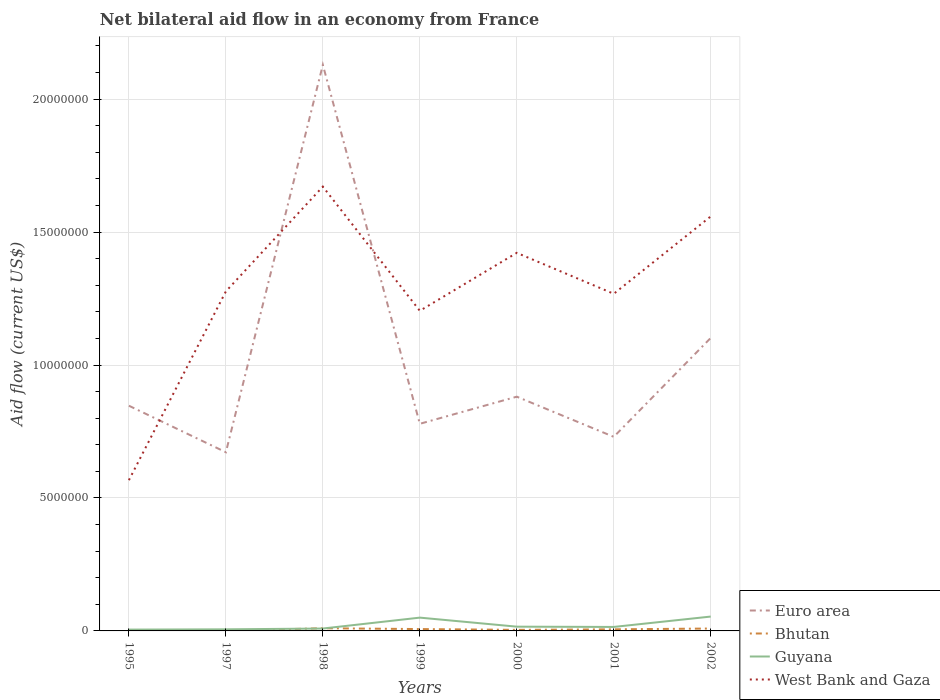How many different coloured lines are there?
Ensure brevity in your answer.  4. Does the line corresponding to Euro area intersect with the line corresponding to West Bank and Gaza?
Provide a succinct answer. Yes. Across all years, what is the maximum net bilateral aid flow in Euro area?
Ensure brevity in your answer.  6.72e+06. What is the total net bilateral aid flow in Euro area in the graph?
Offer a very short reply. -2.21e+06. What is the difference between the highest and the lowest net bilateral aid flow in West Bank and Gaza?
Your response must be concise. 3. Is the net bilateral aid flow in Euro area strictly greater than the net bilateral aid flow in West Bank and Gaza over the years?
Provide a short and direct response. No. How many years are there in the graph?
Your answer should be compact. 7. What is the difference between two consecutive major ticks on the Y-axis?
Give a very brief answer. 5.00e+06. Are the values on the major ticks of Y-axis written in scientific E-notation?
Ensure brevity in your answer.  No. Does the graph contain any zero values?
Keep it short and to the point. No. Does the graph contain grids?
Keep it short and to the point. Yes. How many legend labels are there?
Offer a very short reply. 4. How are the legend labels stacked?
Make the answer very short. Vertical. What is the title of the graph?
Keep it short and to the point. Net bilateral aid flow in an economy from France. Does "Armenia" appear as one of the legend labels in the graph?
Provide a succinct answer. No. What is the Aid flow (current US$) of Euro area in 1995?
Your answer should be compact. 8.47e+06. What is the Aid flow (current US$) of Bhutan in 1995?
Your response must be concise. 3.00e+04. What is the Aid flow (current US$) in West Bank and Gaza in 1995?
Offer a terse response. 5.67e+06. What is the Aid flow (current US$) of Euro area in 1997?
Ensure brevity in your answer.  6.72e+06. What is the Aid flow (current US$) in Bhutan in 1997?
Keep it short and to the point. 10000. What is the Aid flow (current US$) in Guyana in 1997?
Your response must be concise. 6.00e+04. What is the Aid flow (current US$) in West Bank and Gaza in 1997?
Make the answer very short. 1.28e+07. What is the Aid flow (current US$) of Euro area in 1998?
Offer a terse response. 2.13e+07. What is the Aid flow (current US$) in Guyana in 1998?
Your response must be concise. 9.00e+04. What is the Aid flow (current US$) in West Bank and Gaza in 1998?
Offer a very short reply. 1.67e+07. What is the Aid flow (current US$) in Euro area in 1999?
Provide a short and direct response. 7.79e+06. What is the Aid flow (current US$) of West Bank and Gaza in 1999?
Give a very brief answer. 1.20e+07. What is the Aid flow (current US$) of Euro area in 2000?
Offer a very short reply. 8.81e+06. What is the Aid flow (current US$) in Guyana in 2000?
Your answer should be compact. 1.60e+05. What is the Aid flow (current US$) in West Bank and Gaza in 2000?
Offer a very short reply. 1.42e+07. What is the Aid flow (current US$) of Euro area in 2001?
Your response must be concise. 7.30e+06. What is the Aid flow (current US$) in West Bank and Gaza in 2001?
Ensure brevity in your answer.  1.27e+07. What is the Aid flow (current US$) in Euro area in 2002?
Your answer should be compact. 1.10e+07. What is the Aid flow (current US$) of Bhutan in 2002?
Offer a very short reply. 9.00e+04. What is the Aid flow (current US$) of Guyana in 2002?
Provide a short and direct response. 5.40e+05. What is the Aid flow (current US$) in West Bank and Gaza in 2002?
Offer a terse response. 1.56e+07. Across all years, what is the maximum Aid flow (current US$) of Euro area?
Provide a short and direct response. 2.13e+07. Across all years, what is the maximum Aid flow (current US$) in Guyana?
Ensure brevity in your answer.  5.40e+05. Across all years, what is the maximum Aid flow (current US$) in West Bank and Gaza?
Your answer should be compact. 1.67e+07. Across all years, what is the minimum Aid flow (current US$) in Euro area?
Your response must be concise. 6.72e+06. Across all years, what is the minimum Aid flow (current US$) of Bhutan?
Provide a short and direct response. 10000. Across all years, what is the minimum Aid flow (current US$) in Guyana?
Provide a short and direct response. 5.00e+04. Across all years, what is the minimum Aid flow (current US$) in West Bank and Gaza?
Make the answer very short. 5.67e+06. What is the total Aid flow (current US$) of Euro area in the graph?
Provide a succinct answer. 7.14e+07. What is the total Aid flow (current US$) in Bhutan in the graph?
Your answer should be very brief. 4.00e+05. What is the total Aid flow (current US$) in Guyana in the graph?
Offer a terse response. 1.55e+06. What is the total Aid flow (current US$) of West Bank and Gaza in the graph?
Provide a succinct answer. 8.97e+07. What is the difference between the Aid flow (current US$) of Euro area in 1995 and that in 1997?
Your answer should be very brief. 1.75e+06. What is the difference between the Aid flow (current US$) of Bhutan in 1995 and that in 1997?
Provide a short and direct response. 2.00e+04. What is the difference between the Aid flow (current US$) of West Bank and Gaza in 1995 and that in 1997?
Give a very brief answer. -7.10e+06. What is the difference between the Aid flow (current US$) in Euro area in 1995 and that in 1998?
Keep it short and to the point. -1.28e+07. What is the difference between the Aid flow (current US$) of Bhutan in 1995 and that in 1998?
Give a very brief answer. -7.00e+04. What is the difference between the Aid flow (current US$) of Guyana in 1995 and that in 1998?
Make the answer very short. -4.00e+04. What is the difference between the Aid flow (current US$) of West Bank and Gaza in 1995 and that in 1998?
Provide a succinct answer. -1.10e+07. What is the difference between the Aid flow (current US$) in Euro area in 1995 and that in 1999?
Your response must be concise. 6.80e+05. What is the difference between the Aid flow (current US$) of Guyana in 1995 and that in 1999?
Ensure brevity in your answer.  -4.50e+05. What is the difference between the Aid flow (current US$) in West Bank and Gaza in 1995 and that in 1999?
Offer a terse response. -6.37e+06. What is the difference between the Aid flow (current US$) of Bhutan in 1995 and that in 2000?
Offer a very short reply. -10000. What is the difference between the Aid flow (current US$) in West Bank and Gaza in 1995 and that in 2000?
Keep it short and to the point. -8.55e+06. What is the difference between the Aid flow (current US$) of Euro area in 1995 and that in 2001?
Keep it short and to the point. 1.17e+06. What is the difference between the Aid flow (current US$) in Bhutan in 1995 and that in 2001?
Offer a very short reply. -3.00e+04. What is the difference between the Aid flow (current US$) of West Bank and Gaza in 1995 and that in 2001?
Ensure brevity in your answer.  -7.01e+06. What is the difference between the Aid flow (current US$) in Euro area in 1995 and that in 2002?
Your answer should be compact. -2.55e+06. What is the difference between the Aid flow (current US$) in Bhutan in 1995 and that in 2002?
Give a very brief answer. -6.00e+04. What is the difference between the Aid flow (current US$) in Guyana in 1995 and that in 2002?
Provide a short and direct response. -4.90e+05. What is the difference between the Aid flow (current US$) in West Bank and Gaza in 1995 and that in 2002?
Offer a terse response. -9.92e+06. What is the difference between the Aid flow (current US$) of Euro area in 1997 and that in 1998?
Make the answer very short. -1.46e+07. What is the difference between the Aid flow (current US$) in West Bank and Gaza in 1997 and that in 1998?
Provide a succinct answer. -3.94e+06. What is the difference between the Aid flow (current US$) of Euro area in 1997 and that in 1999?
Provide a short and direct response. -1.07e+06. What is the difference between the Aid flow (current US$) in Guyana in 1997 and that in 1999?
Provide a succinct answer. -4.40e+05. What is the difference between the Aid flow (current US$) in West Bank and Gaza in 1997 and that in 1999?
Ensure brevity in your answer.  7.30e+05. What is the difference between the Aid flow (current US$) in Euro area in 1997 and that in 2000?
Offer a very short reply. -2.09e+06. What is the difference between the Aid flow (current US$) in Bhutan in 1997 and that in 2000?
Your answer should be compact. -3.00e+04. What is the difference between the Aid flow (current US$) of Guyana in 1997 and that in 2000?
Offer a very short reply. -1.00e+05. What is the difference between the Aid flow (current US$) in West Bank and Gaza in 1997 and that in 2000?
Provide a succinct answer. -1.45e+06. What is the difference between the Aid flow (current US$) of Euro area in 1997 and that in 2001?
Give a very brief answer. -5.80e+05. What is the difference between the Aid flow (current US$) of Guyana in 1997 and that in 2001?
Make the answer very short. -9.00e+04. What is the difference between the Aid flow (current US$) in Euro area in 1997 and that in 2002?
Provide a short and direct response. -4.30e+06. What is the difference between the Aid flow (current US$) of Bhutan in 1997 and that in 2002?
Offer a very short reply. -8.00e+04. What is the difference between the Aid flow (current US$) in Guyana in 1997 and that in 2002?
Provide a short and direct response. -4.80e+05. What is the difference between the Aid flow (current US$) in West Bank and Gaza in 1997 and that in 2002?
Offer a very short reply. -2.82e+06. What is the difference between the Aid flow (current US$) of Euro area in 1998 and that in 1999?
Provide a succinct answer. 1.35e+07. What is the difference between the Aid flow (current US$) of Bhutan in 1998 and that in 1999?
Offer a very short reply. 3.00e+04. What is the difference between the Aid flow (current US$) in Guyana in 1998 and that in 1999?
Provide a succinct answer. -4.10e+05. What is the difference between the Aid flow (current US$) of West Bank and Gaza in 1998 and that in 1999?
Your answer should be very brief. 4.67e+06. What is the difference between the Aid flow (current US$) of Euro area in 1998 and that in 2000?
Make the answer very short. 1.25e+07. What is the difference between the Aid flow (current US$) in West Bank and Gaza in 1998 and that in 2000?
Ensure brevity in your answer.  2.49e+06. What is the difference between the Aid flow (current US$) in Euro area in 1998 and that in 2001?
Make the answer very short. 1.40e+07. What is the difference between the Aid flow (current US$) of Bhutan in 1998 and that in 2001?
Provide a succinct answer. 4.00e+04. What is the difference between the Aid flow (current US$) in West Bank and Gaza in 1998 and that in 2001?
Provide a succinct answer. 4.03e+06. What is the difference between the Aid flow (current US$) in Euro area in 1998 and that in 2002?
Your answer should be compact. 1.03e+07. What is the difference between the Aid flow (current US$) of Bhutan in 1998 and that in 2002?
Your response must be concise. 10000. What is the difference between the Aid flow (current US$) of Guyana in 1998 and that in 2002?
Your answer should be compact. -4.50e+05. What is the difference between the Aid flow (current US$) of West Bank and Gaza in 1998 and that in 2002?
Give a very brief answer. 1.12e+06. What is the difference between the Aid flow (current US$) in Euro area in 1999 and that in 2000?
Provide a succinct answer. -1.02e+06. What is the difference between the Aid flow (current US$) of West Bank and Gaza in 1999 and that in 2000?
Your answer should be compact. -2.18e+06. What is the difference between the Aid flow (current US$) in Euro area in 1999 and that in 2001?
Your answer should be very brief. 4.90e+05. What is the difference between the Aid flow (current US$) of Guyana in 1999 and that in 2001?
Your response must be concise. 3.50e+05. What is the difference between the Aid flow (current US$) of West Bank and Gaza in 1999 and that in 2001?
Offer a very short reply. -6.40e+05. What is the difference between the Aid flow (current US$) of Euro area in 1999 and that in 2002?
Make the answer very short. -3.23e+06. What is the difference between the Aid flow (current US$) of Bhutan in 1999 and that in 2002?
Provide a succinct answer. -2.00e+04. What is the difference between the Aid flow (current US$) of West Bank and Gaza in 1999 and that in 2002?
Provide a short and direct response. -3.55e+06. What is the difference between the Aid flow (current US$) of Euro area in 2000 and that in 2001?
Offer a terse response. 1.51e+06. What is the difference between the Aid flow (current US$) in Guyana in 2000 and that in 2001?
Your answer should be very brief. 10000. What is the difference between the Aid flow (current US$) of West Bank and Gaza in 2000 and that in 2001?
Ensure brevity in your answer.  1.54e+06. What is the difference between the Aid flow (current US$) of Euro area in 2000 and that in 2002?
Keep it short and to the point. -2.21e+06. What is the difference between the Aid flow (current US$) in Guyana in 2000 and that in 2002?
Keep it short and to the point. -3.80e+05. What is the difference between the Aid flow (current US$) in West Bank and Gaza in 2000 and that in 2002?
Keep it short and to the point. -1.37e+06. What is the difference between the Aid flow (current US$) in Euro area in 2001 and that in 2002?
Offer a very short reply. -3.72e+06. What is the difference between the Aid flow (current US$) of Bhutan in 2001 and that in 2002?
Offer a terse response. -3.00e+04. What is the difference between the Aid flow (current US$) of Guyana in 2001 and that in 2002?
Your response must be concise. -3.90e+05. What is the difference between the Aid flow (current US$) in West Bank and Gaza in 2001 and that in 2002?
Keep it short and to the point. -2.91e+06. What is the difference between the Aid flow (current US$) in Euro area in 1995 and the Aid flow (current US$) in Bhutan in 1997?
Ensure brevity in your answer.  8.46e+06. What is the difference between the Aid flow (current US$) in Euro area in 1995 and the Aid flow (current US$) in Guyana in 1997?
Keep it short and to the point. 8.41e+06. What is the difference between the Aid flow (current US$) of Euro area in 1995 and the Aid flow (current US$) of West Bank and Gaza in 1997?
Your answer should be compact. -4.30e+06. What is the difference between the Aid flow (current US$) in Bhutan in 1995 and the Aid flow (current US$) in West Bank and Gaza in 1997?
Make the answer very short. -1.27e+07. What is the difference between the Aid flow (current US$) in Guyana in 1995 and the Aid flow (current US$) in West Bank and Gaza in 1997?
Your answer should be very brief. -1.27e+07. What is the difference between the Aid flow (current US$) in Euro area in 1995 and the Aid flow (current US$) in Bhutan in 1998?
Your answer should be compact. 8.37e+06. What is the difference between the Aid flow (current US$) of Euro area in 1995 and the Aid flow (current US$) of Guyana in 1998?
Give a very brief answer. 8.38e+06. What is the difference between the Aid flow (current US$) in Euro area in 1995 and the Aid flow (current US$) in West Bank and Gaza in 1998?
Your answer should be compact. -8.24e+06. What is the difference between the Aid flow (current US$) of Bhutan in 1995 and the Aid flow (current US$) of West Bank and Gaza in 1998?
Ensure brevity in your answer.  -1.67e+07. What is the difference between the Aid flow (current US$) in Guyana in 1995 and the Aid flow (current US$) in West Bank and Gaza in 1998?
Give a very brief answer. -1.67e+07. What is the difference between the Aid flow (current US$) of Euro area in 1995 and the Aid flow (current US$) of Bhutan in 1999?
Your answer should be very brief. 8.40e+06. What is the difference between the Aid flow (current US$) in Euro area in 1995 and the Aid flow (current US$) in Guyana in 1999?
Provide a short and direct response. 7.97e+06. What is the difference between the Aid flow (current US$) of Euro area in 1995 and the Aid flow (current US$) of West Bank and Gaza in 1999?
Your answer should be very brief. -3.57e+06. What is the difference between the Aid flow (current US$) in Bhutan in 1995 and the Aid flow (current US$) in Guyana in 1999?
Offer a very short reply. -4.70e+05. What is the difference between the Aid flow (current US$) in Bhutan in 1995 and the Aid flow (current US$) in West Bank and Gaza in 1999?
Offer a very short reply. -1.20e+07. What is the difference between the Aid flow (current US$) of Guyana in 1995 and the Aid flow (current US$) of West Bank and Gaza in 1999?
Ensure brevity in your answer.  -1.20e+07. What is the difference between the Aid flow (current US$) in Euro area in 1995 and the Aid flow (current US$) in Bhutan in 2000?
Ensure brevity in your answer.  8.43e+06. What is the difference between the Aid flow (current US$) of Euro area in 1995 and the Aid flow (current US$) of Guyana in 2000?
Ensure brevity in your answer.  8.31e+06. What is the difference between the Aid flow (current US$) in Euro area in 1995 and the Aid flow (current US$) in West Bank and Gaza in 2000?
Offer a very short reply. -5.75e+06. What is the difference between the Aid flow (current US$) in Bhutan in 1995 and the Aid flow (current US$) in West Bank and Gaza in 2000?
Provide a succinct answer. -1.42e+07. What is the difference between the Aid flow (current US$) of Guyana in 1995 and the Aid flow (current US$) of West Bank and Gaza in 2000?
Your answer should be compact. -1.42e+07. What is the difference between the Aid flow (current US$) in Euro area in 1995 and the Aid flow (current US$) in Bhutan in 2001?
Make the answer very short. 8.41e+06. What is the difference between the Aid flow (current US$) in Euro area in 1995 and the Aid flow (current US$) in Guyana in 2001?
Provide a short and direct response. 8.32e+06. What is the difference between the Aid flow (current US$) in Euro area in 1995 and the Aid flow (current US$) in West Bank and Gaza in 2001?
Make the answer very short. -4.21e+06. What is the difference between the Aid flow (current US$) of Bhutan in 1995 and the Aid flow (current US$) of Guyana in 2001?
Offer a very short reply. -1.20e+05. What is the difference between the Aid flow (current US$) in Bhutan in 1995 and the Aid flow (current US$) in West Bank and Gaza in 2001?
Give a very brief answer. -1.26e+07. What is the difference between the Aid flow (current US$) in Guyana in 1995 and the Aid flow (current US$) in West Bank and Gaza in 2001?
Offer a very short reply. -1.26e+07. What is the difference between the Aid flow (current US$) of Euro area in 1995 and the Aid flow (current US$) of Bhutan in 2002?
Give a very brief answer. 8.38e+06. What is the difference between the Aid flow (current US$) of Euro area in 1995 and the Aid flow (current US$) of Guyana in 2002?
Provide a short and direct response. 7.93e+06. What is the difference between the Aid flow (current US$) of Euro area in 1995 and the Aid flow (current US$) of West Bank and Gaza in 2002?
Offer a very short reply. -7.12e+06. What is the difference between the Aid flow (current US$) in Bhutan in 1995 and the Aid flow (current US$) in Guyana in 2002?
Provide a succinct answer. -5.10e+05. What is the difference between the Aid flow (current US$) of Bhutan in 1995 and the Aid flow (current US$) of West Bank and Gaza in 2002?
Keep it short and to the point. -1.56e+07. What is the difference between the Aid flow (current US$) in Guyana in 1995 and the Aid flow (current US$) in West Bank and Gaza in 2002?
Make the answer very short. -1.55e+07. What is the difference between the Aid flow (current US$) of Euro area in 1997 and the Aid flow (current US$) of Bhutan in 1998?
Offer a terse response. 6.62e+06. What is the difference between the Aid flow (current US$) in Euro area in 1997 and the Aid flow (current US$) in Guyana in 1998?
Offer a very short reply. 6.63e+06. What is the difference between the Aid flow (current US$) in Euro area in 1997 and the Aid flow (current US$) in West Bank and Gaza in 1998?
Ensure brevity in your answer.  -9.99e+06. What is the difference between the Aid flow (current US$) in Bhutan in 1997 and the Aid flow (current US$) in Guyana in 1998?
Give a very brief answer. -8.00e+04. What is the difference between the Aid flow (current US$) of Bhutan in 1997 and the Aid flow (current US$) of West Bank and Gaza in 1998?
Your answer should be very brief. -1.67e+07. What is the difference between the Aid flow (current US$) in Guyana in 1997 and the Aid flow (current US$) in West Bank and Gaza in 1998?
Provide a short and direct response. -1.66e+07. What is the difference between the Aid flow (current US$) of Euro area in 1997 and the Aid flow (current US$) of Bhutan in 1999?
Your response must be concise. 6.65e+06. What is the difference between the Aid flow (current US$) of Euro area in 1997 and the Aid flow (current US$) of Guyana in 1999?
Make the answer very short. 6.22e+06. What is the difference between the Aid flow (current US$) of Euro area in 1997 and the Aid flow (current US$) of West Bank and Gaza in 1999?
Provide a succinct answer. -5.32e+06. What is the difference between the Aid flow (current US$) in Bhutan in 1997 and the Aid flow (current US$) in Guyana in 1999?
Ensure brevity in your answer.  -4.90e+05. What is the difference between the Aid flow (current US$) in Bhutan in 1997 and the Aid flow (current US$) in West Bank and Gaza in 1999?
Give a very brief answer. -1.20e+07. What is the difference between the Aid flow (current US$) of Guyana in 1997 and the Aid flow (current US$) of West Bank and Gaza in 1999?
Your answer should be compact. -1.20e+07. What is the difference between the Aid flow (current US$) in Euro area in 1997 and the Aid flow (current US$) in Bhutan in 2000?
Provide a succinct answer. 6.68e+06. What is the difference between the Aid flow (current US$) in Euro area in 1997 and the Aid flow (current US$) in Guyana in 2000?
Your answer should be very brief. 6.56e+06. What is the difference between the Aid flow (current US$) of Euro area in 1997 and the Aid flow (current US$) of West Bank and Gaza in 2000?
Keep it short and to the point. -7.50e+06. What is the difference between the Aid flow (current US$) in Bhutan in 1997 and the Aid flow (current US$) in West Bank and Gaza in 2000?
Give a very brief answer. -1.42e+07. What is the difference between the Aid flow (current US$) of Guyana in 1997 and the Aid flow (current US$) of West Bank and Gaza in 2000?
Provide a succinct answer. -1.42e+07. What is the difference between the Aid flow (current US$) in Euro area in 1997 and the Aid flow (current US$) in Bhutan in 2001?
Your answer should be very brief. 6.66e+06. What is the difference between the Aid flow (current US$) of Euro area in 1997 and the Aid flow (current US$) of Guyana in 2001?
Offer a terse response. 6.57e+06. What is the difference between the Aid flow (current US$) in Euro area in 1997 and the Aid flow (current US$) in West Bank and Gaza in 2001?
Ensure brevity in your answer.  -5.96e+06. What is the difference between the Aid flow (current US$) in Bhutan in 1997 and the Aid flow (current US$) in West Bank and Gaza in 2001?
Your response must be concise. -1.27e+07. What is the difference between the Aid flow (current US$) in Guyana in 1997 and the Aid flow (current US$) in West Bank and Gaza in 2001?
Your answer should be very brief. -1.26e+07. What is the difference between the Aid flow (current US$) in Euro area in 1997 and the Aid flow (current US$) in Bhutan in 2002?
Your response must be concise. 6.63e+06. What is the difference between the Aid flow (current US$) in Euro area in 1997 and the Aid flow (current US$) in Guyana in 2002?
Give a very brief answer. 6.18e+06. What is the difference between the Aid flow (current US$) of Euro area in 1997 and the Aid flow (current US$) of West Bank and Gaza in 2002?
Your answer should be very brief. -8.87e+06. What is the difference between the Aid flow (current US$) in Bhutan in 1997 and the Aid flow (current US$) in Guyana in 2002?
Your answer should be very brief. -5.30e+05. What is the difference between the Aid flow (current US$) of Bhutan in 1997 and the Aid flow (current US$) of West Bank and Gaza in 2002?
Your response must be concise. -1.56e+07. What is the difference between the Aid flow (current US$) of Guyana in 1997 and the Aid flow (current US$) of West Bank and Gaza in 2002?
Your response must be concise. -1.55e+07. What is the difference between the Aid flow (current US$) in Euro area in 1998 and the Aid flow (current US$) in Bhutan in 1999?
Give a very brief answer. 2.12e+07. What is the difference between the Aid flow (current US$) of Euro area in 1998 and the Aid flow (current US$) of Guyana in 1999?
Offer a terse response. 2.08e+07. What is the difference between the Aid flow (current US$) in Euro area in 1998 and the Aid flow (current US$) in West Bank and Gaza in 1999?
Offer a terse response. 9.25e+06. What is the difference between the Aid flow (current US$) of Bhutan in 1998 and the Aid flow (current US$) of Guyana in 1999?
Your response must be concise. -4.00e+05. What is the difference between the Aid flow (current US$) in Bhutan in 1998 and the Aid flow (current US$) in West Bank and Gaza in 1999?
Give a very brief answer. -1.19e+07. What is the difference between the Aid flow (current US$) in Guyana in 1998 and the Aid flow (current US$) in West Bank and Gaza in 1999?
Provide a succinct answer. -1.20e+07. What is the difference between the Aid flow (current US$) of Euro area in 1998 and the Aid flow (current US$) of Bhutan in 2000?
Provide a succinct answer. 2.12e+07. What is the difference between the Aid flow (current US$) in Euro area in 1998 and the Aid flow (current US$) in Guyana in 2000?
Keep it short and to the point. 2.11e+07. What is the difference between the Aid flow (current US$) in Euro area in 1998 and the Aid flow (current US$) in West Bank and Gaza in 2000?
Make the answer very short. 7.07e+06. What is the difference between the Aid flow (current US$) in Bhutan in 1998 and the Aid flow (current US$) in Guyana in 2000?
Your answer should be compact. -6.00e+04. What is the difference between the Aid flow (current US$) of Bhutan in 1998 and the Aid flow (current US$) of West Bank and Gaza in 2000?
Provide a short and direct response. -1.41e+07. What is the difference between the Aid flow (current US$) in Guyana in 1998 and the Aid flow (current US$) in West Bank and Gaza in 2000?
Provide a short and direct response. -1.41e+07. What is the difference between the Aid flow (current US$) in Euro area in 1998 and the Aid flow (current US$) in Bhutan in 2001?
Offer a very short reply. 2.12e+07. What is the difference between the Aid flow (current US$) of Euro area in 1998 and the Aid flow (current US$) of Guyana in 2001?
Offer a terse response. 2.11e+07. What is the difference between the Aid flow (current US$) in Euro area in 1998 and the Aid flow (current US$) in West Bank and Gaza in 2001?
Offer a terse response. 8.61e+06. What is the difference between the Aid flow (current US$) in Bhutan in 1998 and the Aid flow (current US$) in Guyana in 2001?
Provide a short and direct response. -5.00e+04. What is the difference between the Aid flow (current US$) in Bhutan in 1998 and the Aid flow (current US$) in West Bank and Gaza in 2001?
Offer a very short reply. -1.26e+07. What is the difference between the Aid flow (current US$) in Guyana in 1998 and the Aid flow (current US$) in West Bank and Gaza in 2001?
Provide a short and direct response. -1.26e+07. What is the difference between the Aid flow (current US$) of Euro area in 1998 and the Aid flow (current US$) of Bhutan in 2002?
Make the answer very short. 2.12e+07. What is the difference between the Aid flow (current US$) of Euro area in 1998 and the Aid flow (current US$) of Guyana in 2002?
Your response must be concise. 2.08e+07. What is the difference between the Aid flow (current US$) of Euro area in 1998 and the Aid flow (current US$) of West Bank and Gaza in 2002?
Make the answer very short. 5.70e+06. What is the difference between the Aid flow (current US$) of Bhutan in 1998 and the Aid flow (current US$) of Guyana in 2002?
Your answer should be very brief. -4.40e+05. What is the difference between the Aid flow (current US$) of Bhutan in 1998 and the Aid flow (current US$) of West Bank and Gaza in 2002?
Offer a very short reply. -1.55e+07. What is the difference between the Aid flow (current US$) of Guyana in 1998 and the Aid flow (current US$) of West Bank and Gaza in 2002?
Offer a very short reply. -1.55e+07. What is the difference between the Aid flow (current US$) in Euro area in 1999 and the Aid flow (current US$) in Bhutan in 2000?
Make the answer very short. 7.75e+06. What is the difference between the Aid flow (current US$) in Euro area in 1999 and the Aid flow (current US$) in Guyana in 2000?
Your response must be concise. 7.63e+06. What is the difference between the Aid flow (current US$) of Euro area in 1999 and the Aid flow (current US$) of West Bank and Gaza in 2000?
Provide a short and direct response. -6.43e+06. What is the difference between the Aid flow (current US$) in Bhutan in 1999 and the Aid flow (current US$) in Guyana in 2000?
Give a very brief answer. -9.00e+04. What is the difference between the Aid flow (current US$) in Bhutan in 1999 and the Aid flow (current US$) in West Bank and Gaza in 2000?
Offer a very short reply. -1.42e+07. What is the difference between the Aid flow (current US$) of Guyana in 1999 and the Aid flow (current US$) of West Bank and Gaza in 2000?
Provide a succinct answer. -1.37e+07. What is the difference between the Aid flow (current US$) in Euro area in 1999 and the Aid flow (current US$) in Bhutan in 2001?
Offer a very short reply. 7.73e+06. What is the difference between the Aid flow (current US$) in Euro area in 1999 and the Aid flow (current US$) in Guyana in 2001?
Offer a very short reply. 7.64e+06. What is the difference between the Aid flow (current US$) in Euro area in 1999 and the Aid flow (current US$) in West Bank and Gaza in 2001?
Make the answer very short. -4.89e+06. What is the difference between the Aid flow (current US$) in Bhutan in 1999 and the Aid flow (current US$) in West Bank and Gaza in 2001?
Ensure brevity in your answer.  -1.26e+07. What is the difference between the Aid flow (current US$) in Guyana in 1999 and the Aid flow (current US$) in West Bank and Gaza in 2001?
Your answer should be very brief. -1.22e+07. What is the difference between the Aid flow (current US$) in Euro area in 1999 and the Aid flow (current US$) in Bhutan in 2002?
Make the answer very short. 7.70e+06. What is the difference between the Aid flow (current US$) in Euro area in 1999 and the Aid flow (current US$) in Guyana in 2002?
Provide a succinct answer. 7.25e+06. What is the difference between the Aid flow (current US$) in Euro area in 1999 and the Aid flow (current US$) in West Bank and Gaza in 2002?
Give a very brief answer. -7.80e+06. What is the difference between the Aid flow (current US$) in Bhutan in 1999 and the Aid flow (current US$) in Guyana in 2002?
Your answer should be very brief. -4.70e+05. What is the difference between the Aid flow (current US$) in Bhutan in 1999 and the Aid flow (current US$) in West Bank and Gaza in 2002?
Give a very brief answer. -1.55e+07. What is the difference between the Aid flow (current US$) in Guyana in 1999 and the Aid flow (current US$) in West Bank and Gaza in 2002?
Ensure brevity in your answer.  -1.51e+07. What is the difference between the Aid flow (current US$) in Euro area in 2000 and the Aid flow (current US$) in Bhutan in 2001?
Your response must be concise. 8.75e+06. What is the difference between the Aid flow (current US$) of Euro area in 2000 and the Aid flow (current US$) of Guyana in 2001?
Offer a terse response. 8.66e+06. What is the difference between the Aid flow (current US$) in Euro area in 2000 and the Aid flow (current US$) in West Bank and Gaza in 2001?
Make the answer very short. -3.87e+06. What is the difference between the Aid flow (current US$) of Bhutan in 2000 and the Aid flow (current US$) of Guyana in 2001?
Provide a succinct answer. -1.10e+05. What is the difference between the Aid flow (current US$) in Bhutan in 2000 and the Aid flow (current US$) in West Bank and Gaza in 2001?
Your response must be concise. -1.26e+07. What is the difference between the Aid flow (current US$) in Guyana in 2000 and the Aid flow (current US$) in West Bank and Gaza in 2001?
Your answer should be compact. -1.25e+07. What is the difference between the Aid flow (current US$) of Euro area in 2000 and the Aid flow (current US$) of Bhutan in 2002?
Keep it short and to the point. 8.72e+06. What is the difference between the Aid flow (current US$) of Euro area in 2000 and the Aid flow (current US$) of Guyana in 2002?
Offer a terse response. 8.27e+06. What is the difference between the Aid flow (current US$) in Euro area in 2000 and the Aid flow (current US$) in West Bank and Gaza in 2002?
Your response must be concise. -6.78e+06. What is the difference between the Aid flow (current US$) in Bhutan in 2000 and the Aid flow (current US$) in Guyana in 2002?
Your answer should be very brief. -5.00e+05. What is the difference between the Aid flow (current US$) of Bhutan in 2000 and the Aid flow (current US$) of West Bank and Gaza in 2002?
Offer a terse response. -1.56e+07. What is the difference between the Aid flow (current US$) in Guyana in 2000 and the Aid flow (current US$) in West Bank and Gaza in 2002?
Provide a succinct answer. -1.54e+07. What is the difference between the Aid flow (current US$) of Euro area in 2001 and the Aid flow (current US$) of Bhutan in 2002?
Make the answer very short. 7.21e+06. What is the difference between the Aid flow (current US$) in Euro area in 2001 and the Aid flow (current US$) in Guyana in 2002?
Give a very brief answer. 6.76e+06. What is the difference between the Aid flow (current US$) in Euro area in 2001 and the Aid flow (current US$) in West Bank and Gaza in 2002?
Offer a terse response. -8.29e+06. What is the difference between the Aid flow (current US$) of Bhutan in 2001 and the Aid flow (current US$) of Guyana in 2002?
Your answer should be very brief. -4.80e+05. What is the difference between the Aid flow (current US$) of Bhutan in 2001 and the Aid flow (current US$) of West Bank and Gaza in 2002?
Offer a very short reply. -1.55e+07. What is the difference between the Aid flow (current US$) in Guyana in 2001 and the Aid flow (current US$) in West Bank and Gaza in 2002?
Offer a terse response. -1.54e+07. What is the average Aid flow (current US$) of Euro area per year?
Keep it short and to the point. 1.02e+07. What is the average Aid flow (current US$) in Bhutan per year?
Offer a terse response. 5.71e+04. What is the average Aid flow (current US$) of Guyana per year?
Offer a very short reply. 2.21e+05. What is the average Aid flow (current US$) of West Bank and Gaza per year?
Offer a terse response. 1.28e+07. In the year 1995, what is the difference between the Aid flow (current US$) in Euro area and Aid flow (current US$) in Bhutan?
Keep it short and to the point. 8.44e+06. In the year 1995, what is the difference between the Aid flow (current US$) in Euro area and Aid flow (current US$) in Guyana?
Keep it short and to the point. 8.42e+06. In the year 1995, what is the difference between the Aid flow (current US$) in Euro area and Aid flow (current US$) in West Bank and Gaza?
Your answer should be compact. 2.80e+06. In the year 1995, what is the difference between the Aid flow (current US$) of Bhutan and Aid flow (current US$) of West Bank and Gaza?
Offer a very short reply. -5.64e+06. In the year 1995, what is the difference between the Aid flow (current US$) in Guyana and Aid flow (current US$) in West Bank and Gaza?
Give a very brief answer. -5.62e+06. In the year 1997, what is the difference between the Aid flow (current US$) in Euro area and Aid flow (current US$) in Bhutan?
Offer a very short reply. 6.71e+06. In the year 1997, what is the difference between the Aid flow (current US$) of Euro area and Aid flow (current US$) of Guyana?
Provide a succinct answer. 6.66e+06. In the year 1997, what is the difference between the Aid flow (current US$) in Euro area and Aid flow (current US$) in West Bank and Gaza?
Ensure brevity in your answer.  -6.05e+06. In the year 1997, what is the difference between the Aid flow (current US$) in Bhutan and Aid flow (current US$) in West Bank and Gaza?
Offer a very short reply. -1.28e+07. In the year 1997, what is the difference between the Aid flow (current US$) in Guyana and Aid flow (current US$) in West Bank and Gaza?
Make the answer very short. -1.27e+07. In the year 1998, what is the difference between the Aid flow (current US$) in Euro area and Aid flow (current US$) in Bhutan?
Offer a very short reply. 2.12e+07. In the year 1998, what is the difference between the Aid flow (current US$) in Euro area and Aid flow (current US$) in Guyana?
Offer a terse response. 2.12e+07. In the year 1998, what is the difference between the Aid flow (current US$) of Euro area and Aid flow (current US$) of West Bank and Gaza?
Provide a short and direct response. 4.58e+06. In the year 1998, what is the difference between the Aid flow (current US$) in Bhutan and Aid flow (current US$) in West Bank and Gaza?
Your answer should be very brief. -1.66e+07. In the year 1998, what is the difference between the Aid flow (current US$) in Guyana and Aid flow (current US$) in West Bank and Gaza?
Your answer should be very brief. -1.66e+07. In the year 1999, what is the difference between the Aid flow (current US$) of Euro area and Aid flow (current US$) of Bhutan?
Provide a short and direct response. 7.72e+06. In the year 1999, what is the difference between the Aid flow (current US$) in Euro area and Aid flow (current US$) in Guyana?
Make the answer very short. 7.29e+06. In the year 1999, what is the difference between the Aid flow (current US$) of Euro area and Aid flow (current US$) of West Bank and Gaza?
Offer a very short reply. -4.25e+06. In the year 1999, what is the difference between the Aid flow (current US$) of Bhutan and Aid flow (current US$) of Guyana?
Your answer should be compact. -4.30e+05. In the year 1999, what is the difference between the Aid flow (current US$) of Bhutan and Aid flow (current US$) of West Bank and Gaza?
Keep it short and to the point. -1.20e+07. In the year 1999, what is the difference between the Aid flow (current US$) in Guyana and Aid flow (current US$) in West Bank and Gaza?
Your response must be concise. -1.15e+07. In the year 2000, what is the difference between the Aid flow (current US$) in Euro area and Aid flow (current US$) in Bhutan?
Offer a very short reply. 8.77e+06. In the year 2000, what is the difference between the Aid flow (current US$) of Euro area and Aid flow (current US$) of Guyana?
Your response must be concise. 8.65e+06. In the year 2000, what is the difference between the Aid flow (current US$) in Euro area and Aid flow (current US$) in West Bank and Gaza?
Keep it short and to the point. -5.41e+06. In the year 2000, what is the difference between the Aid flow (current US$) in Bhutan and Aid flow (current US$) in West Bank and Gaza?
Offer a very short reply. -1.42e+07. In the year 2000, what is the difference between the Aid flow (current US$) in Guyana and Aid flow (current US$) in West Bank and Gaza?
Provide a short and direct response. -1.41e+07. In the year 2001, what is the difference between the Aid flow (current US$) of Euro area and Aid flow (current US$) of Bhutan?
Offer a very short reply. 7.24e+06. In the year 2001, what is the difference between the Aid flow (current US$) in Euro area and Aid flow (current US$) in Guyana?
Your answer should be very brief. 7.15e+06. In the year 2001, what is the difference between the Aid flow (current US$) of Euro area and Aid flow (current US$) of West Bank and Gaza?
Your response must be concise. -5.38e+06. In the year 2001, what is the difference between the Aid flow (current US$) in Bhutan and Aid flow (current US$) in Guyana?
Offer a terse response. -9.00e+04. In the year 2001, what is the difference between the Aid flow (current US$) of Bhutan and Aid flow (current US$) of West Bank and Gaza?
Make the answer very short. -1.26e+07. In the year 2001, what is the difference between the Aid flow (current US$) of Guyana and Aid flow (current US$) of West Bank and Gaza?
Your answer should be compact. -1.25e+07. In the year 2002, what is the difference between the Aid flow (current US$) in Euro area and Aid flow (current US$) in Bhutan?
Provide a succinct answer. 1.09e+07. In the year 2002, what is the difference between the Aid flow (current US$) of Euro area and Aid flow (current US$) of Guyana?
Give a very brief answer. 1.05e+07. In the year 2002, what is the difference between the Aid flow (current US$) of Euro area and Aid flow (current US$) of West Bank and Gaza?
Ensure brevity in your answer.  -4.57e+06. In the year 2002, what is the difference between the Aid flow (current US$) of Bhutan and Aid flow (current US$) of Guyana?
Give a very brief answer. -4.50e+05. In the year 2002, what is the difference between the Aid flow (current US$) of Bhutan and Aid flow (current US$) of West Bank and Gaza?
Keep it short and to the point. -1.55e+07. In the year 2002, what is the difference between the Aid flow (current US$) of Guyana and Aid flow (current US$) of West Bank and Gaza?
Provide a succinct answer. -1.50e+07. What is the ratio of the Aid flow (current US$) of Euro area in 1995 to that in 1997?
Provide a short and direct response. 1.26. What is the ratio of the Aid flow (current US$) in West Bank and Gaza in 1995 to that in 1997?
Keep it short and to the point. 0.44. What is the ratio of the Aid flow (current US$) of Euro area in 1995 to that in 1998?
Ensure brevity in your answer.  0.4. What is the ratio of the Aid flow (current US$) of Guyana in 1995 to that in 1998?
Offer a very short reply. 0.56. What is the ratio of the Aid flow (current US$) in West Bank and Gaza in 1995 to that in 1998?
Offer a very short reply. 0.34. What is the ratio of the Aid flow (current US$) of Euro area in 1995 to that in 1999?
Ensure brevity in your answer.  1.09. What is the ratio of the Aid flow (current US$) of Bhutan in 1995 to that in 1999?
Your answer should be very brief. 0.43. What is the ratio of the Aid flow (current US$) of Guyana in 1995 to that in 1999?
Offer a terse response. 0.1. What is the ratio of the Aid flow (current US$) in West Bank and Gaza in 1995 to that in 1999?
Make the answer very short. 0.47. What is the ratio of the Aid flow (current US$) of Euro area in 1995 to that in 2000?
Your answer should be very brief. 0.96. What is the ratio of the Aid flow (current US$) of Guyana in 1995 to that in 2000?
Provide a succinct answer. 0.31. What is the ratio of the Aid flow (current US$) of West Bank and Gaza in 1995 to that in 2000?
Your answer should be very brief. 0.4. What is the ratio of the Aid flow (current US$) of Euro area in 1995 to that in 2001?
Offer a terse response. 1.16. What is the ratio of the Aid flow (current US$) of Bhutan in 1995 to that in 2001?
Your answer should be compact. 0.5. What is the ratio of the Aid flow (current US$) in Guyana in 1995 to that in 2001?
Your answer should be very brief. 0.33. What is the ratio of the Aid flow (current US$) of West Bank and Gaza in 1995 to that in 2001?
Give a very brief answer. 0.45. What is the ratio of the Aid flow (current US$) in Euro area in 1995 to that in 2002?
Make the answer very short. 0.77. What is the ratio of the Aid flow (current US$) in Bhutan in 1995 to that in 2002?
Provide a succinct answer. 0.33. What is the ratio of the Aid flow (current US$) of Guyana in 1995 to that in 2002?
Keep it short and to the point. 0.09. What is the ratio of the Aid flow (current US$) of West Bank and Gaza in 1995 to that in 2002?
Offer a terse response. 0.36. What is the ratio of the Aid flow (current US$) of Euro area in 1997 to that in 1998?
Ensure brevity in your answer.  0.32. What is the ratio of the Aid flow (current US$) in Bhutan in 1997 to that in 1998?
Your answer should be compact. 0.1. What is the ratio of the Aid flow (current US$) in West Bank and Gaza in 1997 to that in 1998?
Your answer should be very brief. 0.76. What is the ratio of the Aid flow (current US$) of Euro area in 1997 to that in 1999?
Provide a succinct answer. 0.86. What is the ratio of the Aid flow (current US$) of Bhutan in 1997 to that in 1999?
Give a very brief answer. 0.14. What is the ratio of the Aid flow (current US$) in Guyana in 1997 to that in 1999?
Your answer should be compact. 0.12. What is the ratio of the Aid flow (current US$) of West Bank and Gaza in 1997 to that in 1999?
Your answer should be very brief. 1.06. What is the ratio of the Aid flow (current US$) of Euro area in 1997 to that in 2000?
Keep it short and to the point. 0.76. What is the ratio of the Aid flow (current US$) of Guyana in 1997 to that in 2000?
Make the answer very short. 0.38. What is the ratio of the Aid flow (current US$) of West Bank and Gaza in 1997 to that in 2000?
Give a very brief answer. 0.9. What is the ratio of the Aid flow (current US$) in Euro area in 1997 to that in 2001?
Your response must be concise. 0.92. What is the ratio of the Aid flow (current US$) of West Bank and Gaza in 1997 to that in 2001?
Give a very brief answer. 1.01. What is the ratio of the Aid flow (current US$) of Euro area in 1997 to that in 2002?
Your answer should be compact. 0.61. What is the ratio of the Aid flow (current US$) of West Bank and Gaza in 1997 to that in 2002?
Your answer should be compact. 0.82. What is the ratio of the Aid flow (current US$) in Euro area in 1998 to that in 1999?
Provide a short and direct response. 2.73. What is the ratio of the Aid flow (current US$) of Bhutan in 1998 to that in 1999?
Provide a short and direct response. 1.43. What is the ratio of the Aid flow (current US$) in Guyana in 1998 to that in 1999?
Offer a terse response. 0.18. What is the ratio of the Aid flow (current US$) in West Bank and Gaza in 1998 to that in 1999?
Provide a short and direct response. 1.39. What is the ratio of the Aid flow (current US$) of Euro area in 1998 to that in 2000?
Make the answer very short. 2.42. What is the ratio of the Aid flow (current US$) of Bhutan in 1998 to that in 2000?
Make the answer very short. 2.5. What is the ratio of the Aid flow (current US$) of Guyana in 1998 to that in 2000?
Your answer should be very brief. 0.56. What is the ratio of the Aid flow (current US$) of West Bank and Gaza in 1998 to that in 2000?
Give a very brief answer. 1.18. What is the ratio of the Aid flow (current US$) in Euro area in 1998 to that in 2001?
Give a very brief answer. 2.92. What is the ratio of the Aid flow (current US$) in Guyana in 1998 to that in 2001?
Provide a succinct answer. 0.6. What is the ratio of the Aid flow (current US$) of West Bank and Gaza in 1998 to that in 2001?
Make the answer very short. 1.32. What is the ratio of the Aid flow (current US$) in Euro area in 1998 to that in 2002?
Provide a succinct answer. 1.93. What is the ratio of the Aid flow (current US$) in Bhutan in 1998 to that in 2002?
Your response must be concise. 1.11. What is the ratio of the Aid flow (current US$) in Guyana in 1998 to that in 2002?
Keep it short and to the point. 0.17. What is the ratio of the Aid flow (current US$) in West Bank and Gaza in 1998 to that in 2002?
Provide a succinct answer. 1.07. What is the ratio of the Aid flow (current US$) in Euro area in 1999 to that in 2000?
Your answer should be compact. 0.88. What is the ratio of the Aid flow (current US$) of Bhutan in 1999 to that in 2000?
Your answer should be very brief. 1.75. What is the ratio of the Aid flow (current US$) in Guyana in 1999 to that in 2000?
Your answer should be compact. 3.12. What is the ratio of the Aid flow (current US$) of West Bank and Gaza in 1999 to that in 2000?
Give a very brief answer. 0.85. What is the ratio of the Aid flow (current US$) of Euro area in 1999 to that in 2001?
Ensure brevity in your answer.  1.07. What is the ratio of the Aid flow (current US$) of West Bank and Gaza in 1999 to that in 2001?
Your answer should be very brief. 0.95. What is the ratio of the Aid flow (current US$) of Euro area in 1999 to that in 2002?
Provide a succinct answer. 0.71. What is the ratio of the Aid flow (current US$) of Bhutan in 1999 to that in 2002?
Provide a short and direct response. 0.78. What is the ratio of the Aid flow (current US$) in Guyana in 1999 to that in 2002?
Keep it short and to the point. 0.93. What is the ratio of the Aid flow (current US$) in West Bank and Gaza in 1999 to that in 2002?
Your answer should be very brief. 0.77. What is the ratio of the Aid flow (current US$) of Euro area in 2000 to that in 2001?
Keep it short and to the point. 1.21. What is the ratio of the Aid flow (current US$) of Bhutan in 2000 to that in 2001?
Ensure brevity in your answer.  0.67. What is the ratio of the Aid flow (current US$) of Guyana in 2000 to that in 2001?
Provide a succinct answer. 1.07. What is the ratio of the Aid flow (current US$) of West Bank and Gaza in 2000 to that in 2001?
Your answer should be very brief. 1.12. What is the ratio of the Aid flow (current US$) in Euro area in 2000 to that in 2002?
Provide a succinct answer. 0.8. What is the ratio of the Aid flow (current US$) of Bhutan in 2000 to that in 2002?
Ensure brevity in your answer.  0.44. What is the ratio of the Aid flow (current US$) in Guyana in 2000 to that in 2002?
Give a very brief answer. 0.3. What is the ratio of the Aid flow (current US$) of West Bank and Gaza in 2000 to that in 2002?
Make the answer very short. 0.91. What is the ratio of the Aid flow (current US$) in Euro area in 2001 to that in 2002?
Ensure brevity in your answer.  0.66. What is the ratio of the Aid flow (current US$) of Guyana in 2001 to that in 2002?
Offer a very short reply. 0.28. What is the ratio of the Aid flow (current US$) in West Bank and Gaza in 2001 to that in 2002?
Give a very brief answer. 0.81. What is the difference between the highest and the second highest Aid flow (current US$) in Euro area?
Your response must be concise. 1.03e+07. What is the difference between the highest and the second highest Aid flow (current US$) in Bhutan?
Offer a very short reply. 10000. What is the difference between the highest and the second highest Aid flow (current US$) of West Bank and Gaza?
Ensure brevity in your answer.  1.12e+06. What is the difference between the highest and the lowest Aid flow (current US$) in Euro area?
Make the answer very short. 1.46e+07. What is the difference between the highest and the lowest Aid flow (current US$) in Bhutan?
Give a very brief answer. 9.00e+04. What is the difference between the highest and the lowest Aid flow (current US$) of West Bank and Gaza?
Provide a short and direct response. 1.10e+07. 